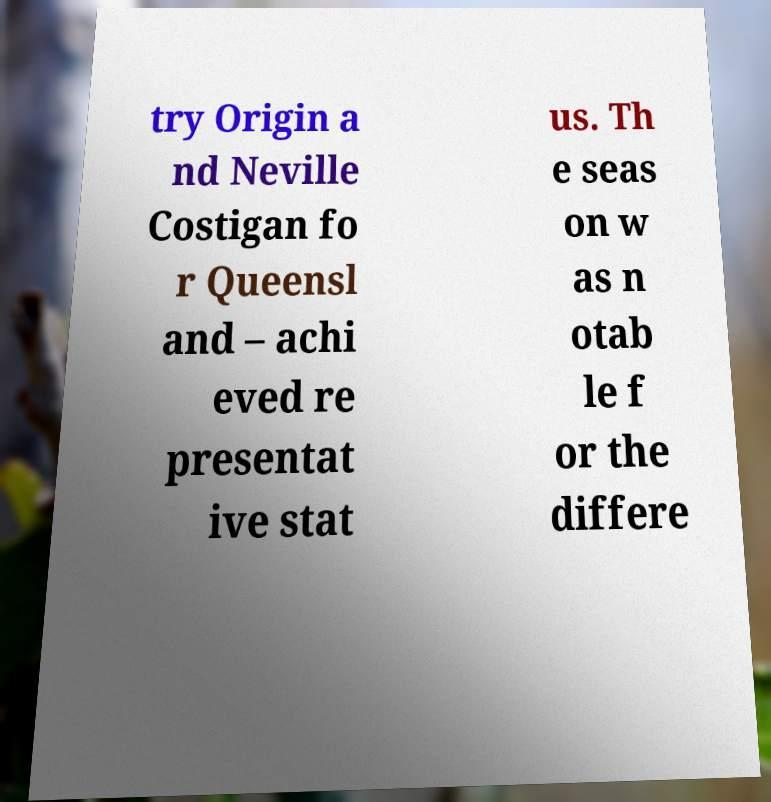For documentation purposes, I need the text within this image transcribed. Could you provide that? try Origin a nd Neville Costigan fo r Queensl and – achi eved re presentat ive stat us. Th e seas on w as n otab le f or the differe 